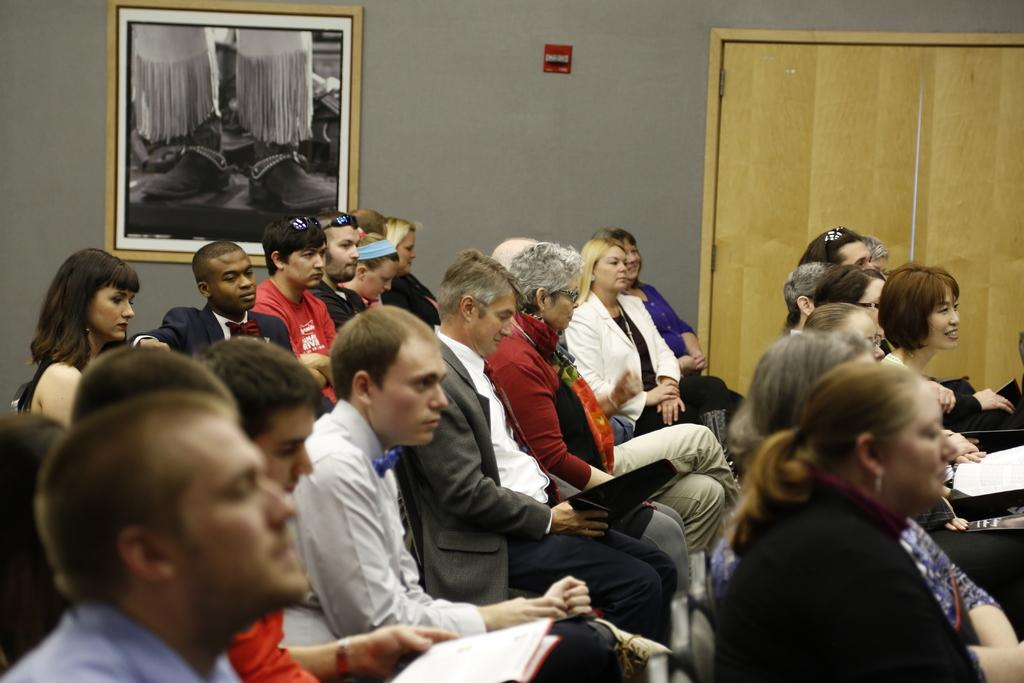Who or what can be seen in the image? There are people in the image. What architectural feature is present in the image? There is a door in the image. What else can be seen in the image besides the people and door? There is a wall in the image. Is there any decoration or object on the wall? Yes, there is a picture on the wall. What are the people in the image doing? The people are sitting. What type of soap is being used by the people in the image? There is no soap present in the image; the people are sitting and not engaged in any activity involving soap. 